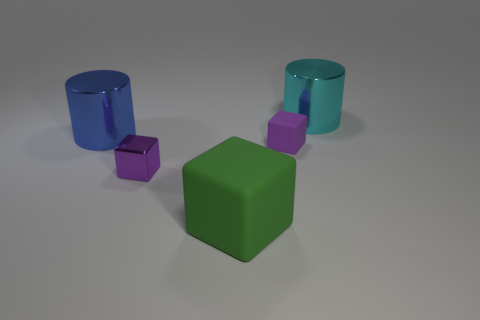Are the tiny cube that is on the left side of the big rubber block and the block right of the green rubber cube made of the same material?
Your answer should be very brief. No. What material is the tiny purple block that is right of the large block?
Keep it short and to the point. Rubber. What number of matte objects are either large green blocks or cubes?
Make the answer very short. 2. What color is the matte object that is on the left side of the block right of the large green thing?
Ensure brevity in your answer.  Green. Does the large green block have the same material as the small purple thing that is to the left of the purple matte object?
Provide a short and direct response. No. What is the color of the large object that is in front of the large cylinder that is to the left of the metal cylinder to the right of the big green matte thing?
Your response must be concise. Green. Is there anything else that has the same shape as the big blue object?
Offer a terse response. Yes. Is the number of big blue rubber cubes greater than the number of shiny blocks?
Provide a succinct answer. No. How many small purple cubes are both to the left of the big green cube and behind the purple shiny object?
Provide a short and direct response. 0. What number of purple blocks are in front of the big metallic thing that is right of the small purple matte object?
Offer a terse response. 2. 